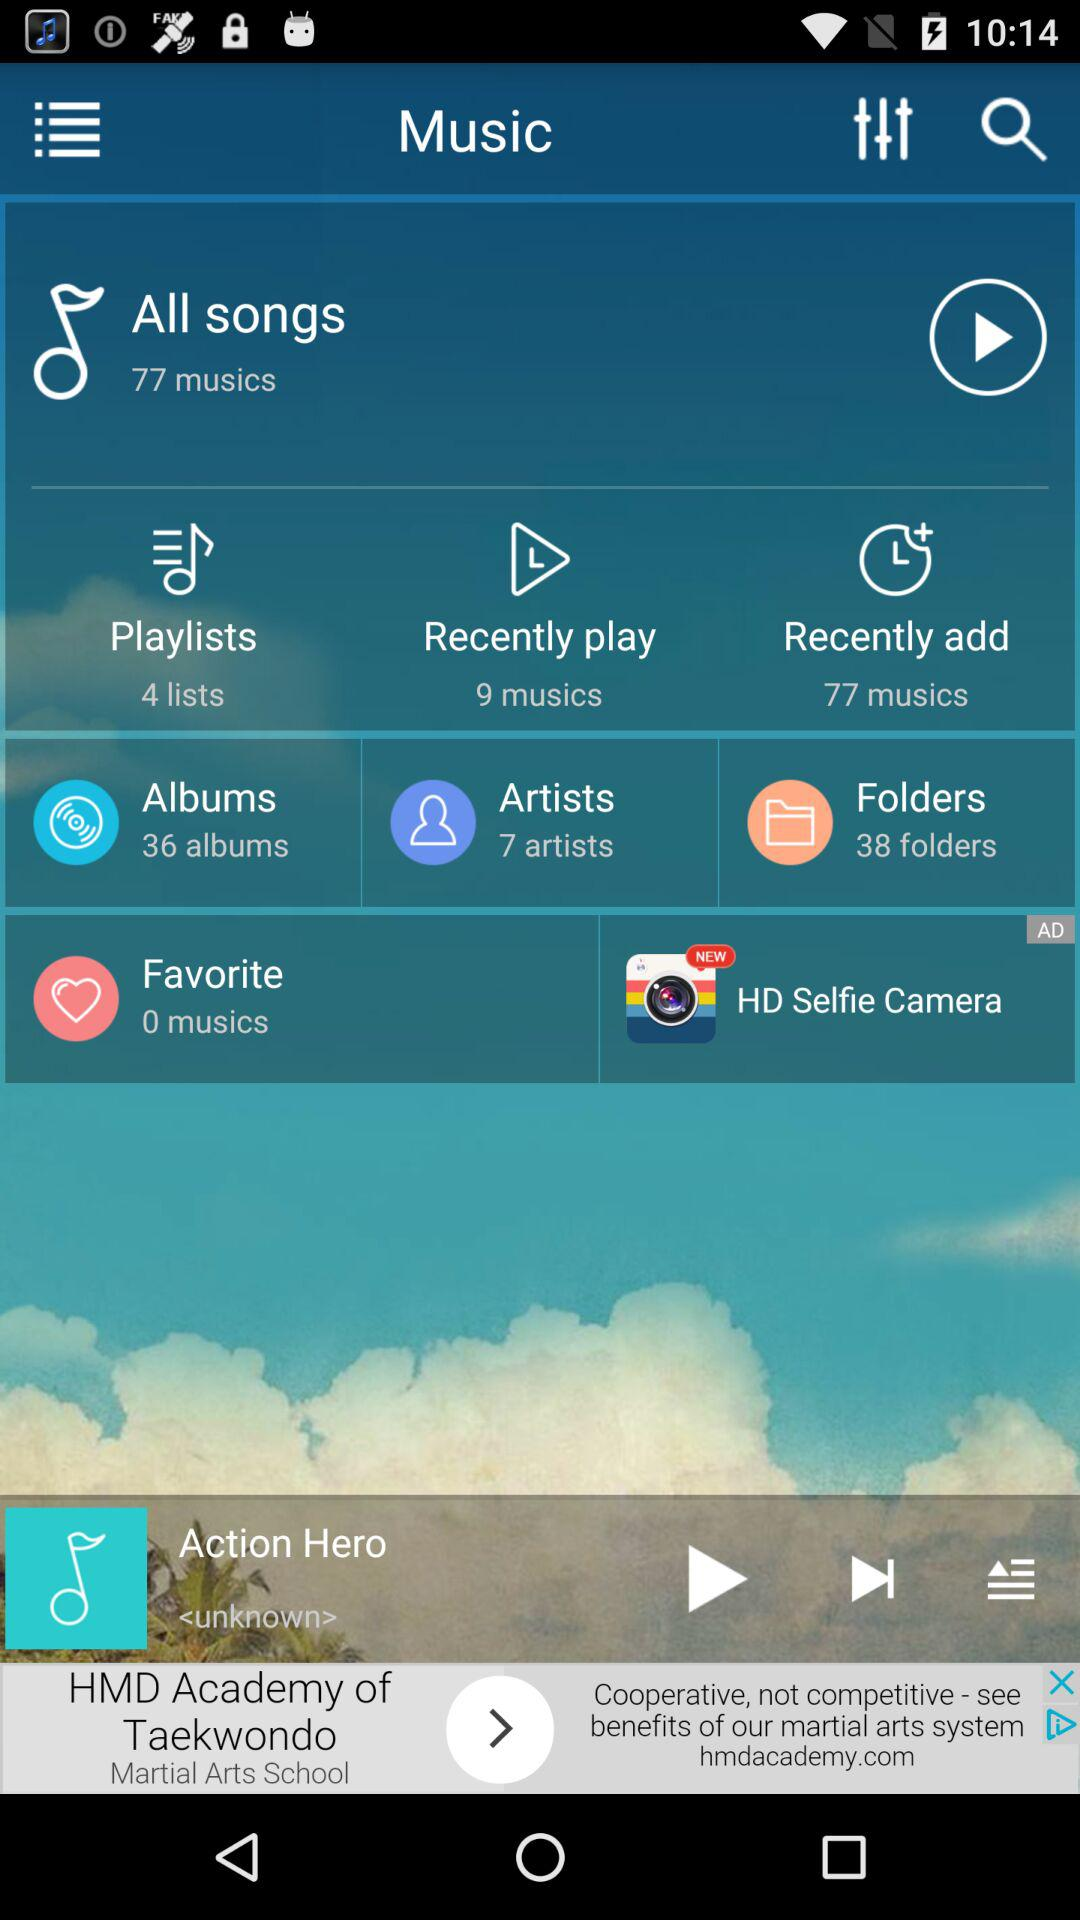How much of the song has been played?
When the provided information is insufficient, respond with <no answer>. <no answer> 